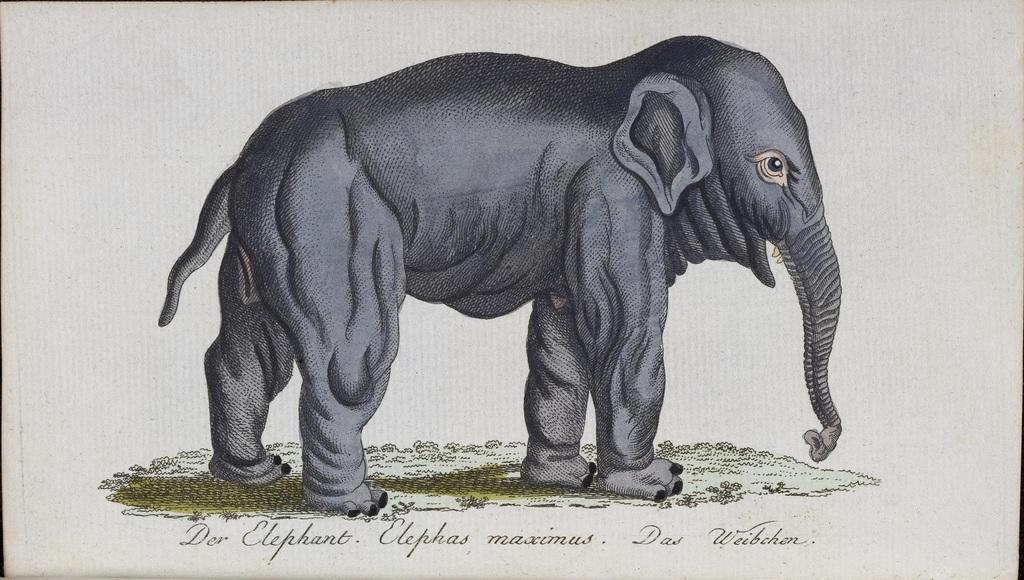What is the medium of the image? The image is on a paper. What is the main subject of the image? There is an elephant in the middle of the image. What color is the elephant in the image? The elephant is in black color. How many pies are being traded in the image? There are no pies or any indication of trade in the image; it features an elephant in black color. 